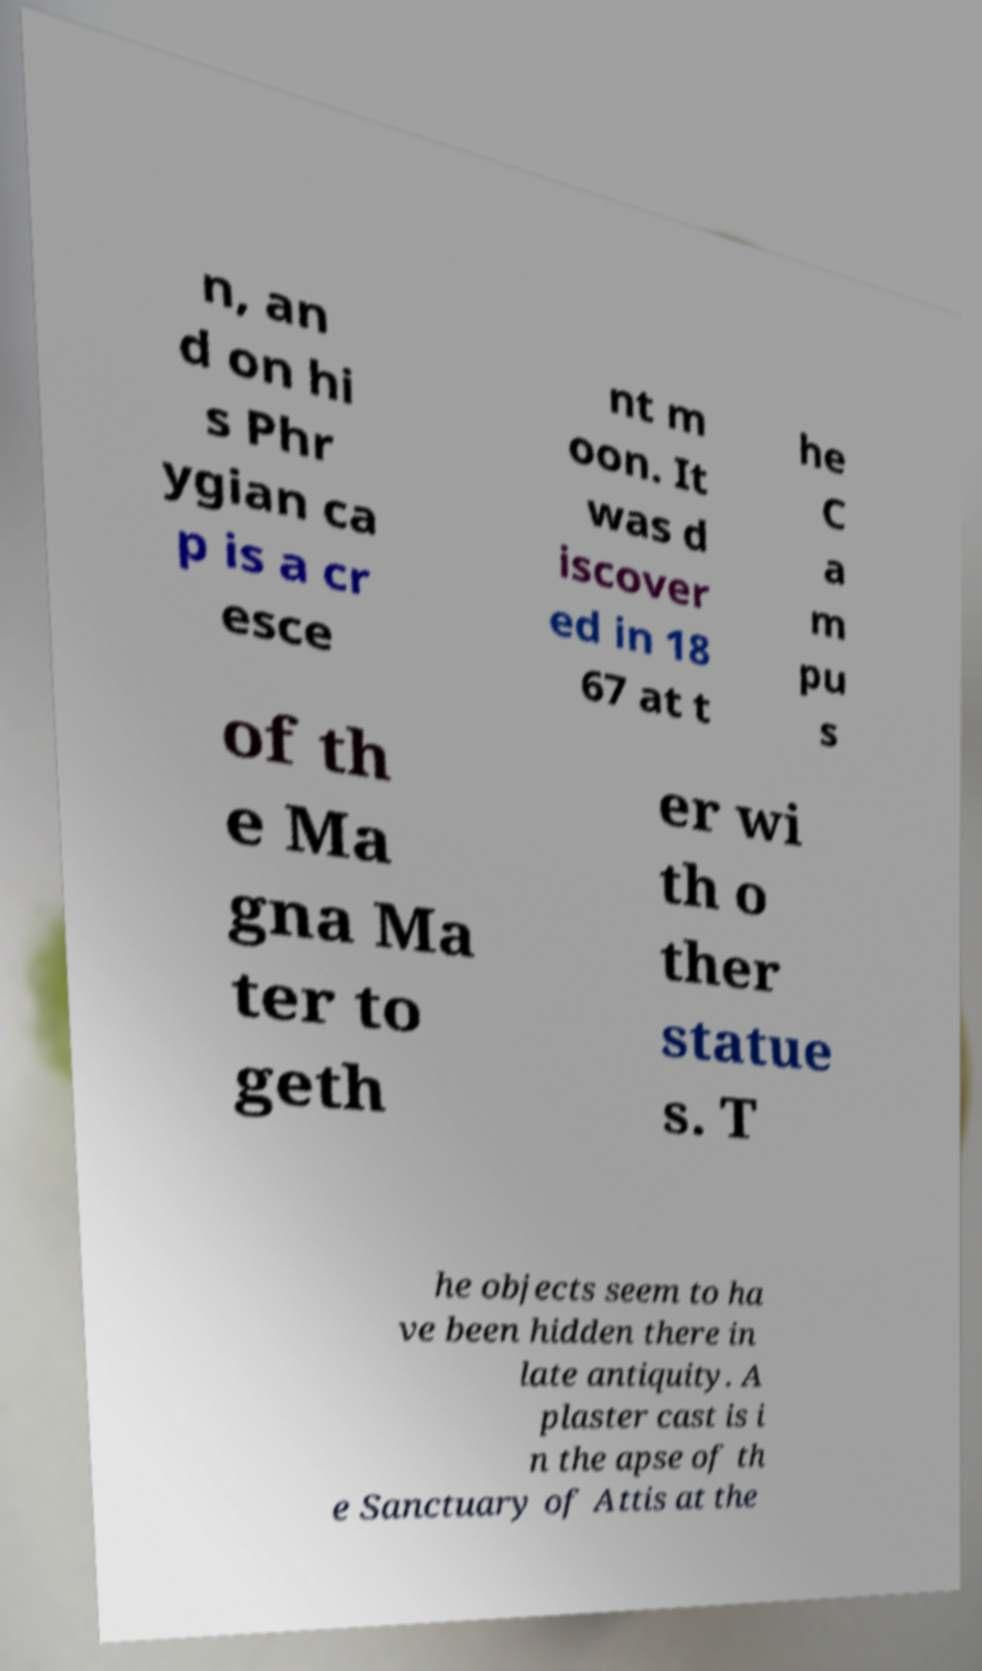Can you read and provide the text displayed in the image?This photo seems to have some interesting text. Can you extract and type it out for me? n, an d on hi s Phr ygian ca p is a cr esce nt m oon. It was d iscover ed in 18 67 at t he C a m pu s of th e Ma gna Ma ter to geth er wi th o ther statue s. T he objects seem to ha ve been hidden there in late antiquity. A plaster cast is i n the apse of th e Sanctuary of Attis at the 